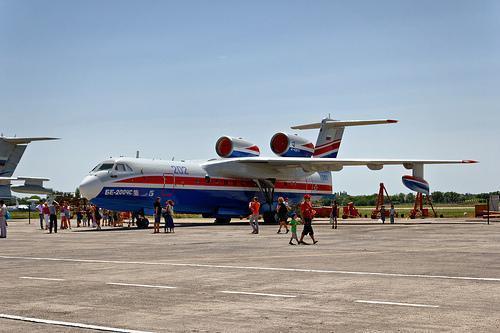How many colors does the jet numbered 202 have on it?
Give a very brief answer. 3. 